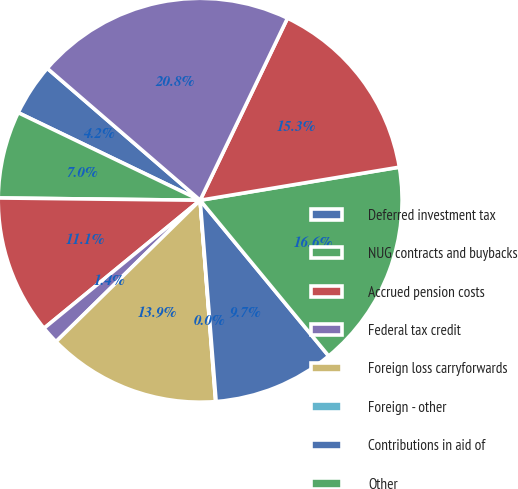<chart> <loc_0><loc_0><loc_500><loc_500><pie_chart><fcel>Deferred investment tax<fcel>NUG contracts and buybacks<fcel>Accrued pension costs<fcel>Federal tax credit<fcel>Foreign loss carryforwards<fcel>Foreign - other<fcel>Contributions in aid of<fcel>Other<fcel>Valuation allowances<fcel>Plant - net<nl><fcel>4.19%<fcel>6.96%<fcel>11.11%<fcel>1.42%<fcel>13.87%<fcel>0.04%<fcel>9.72%<fcel>16.64%<fcel>15.26%<fcel>20.79%<nl></chart> 